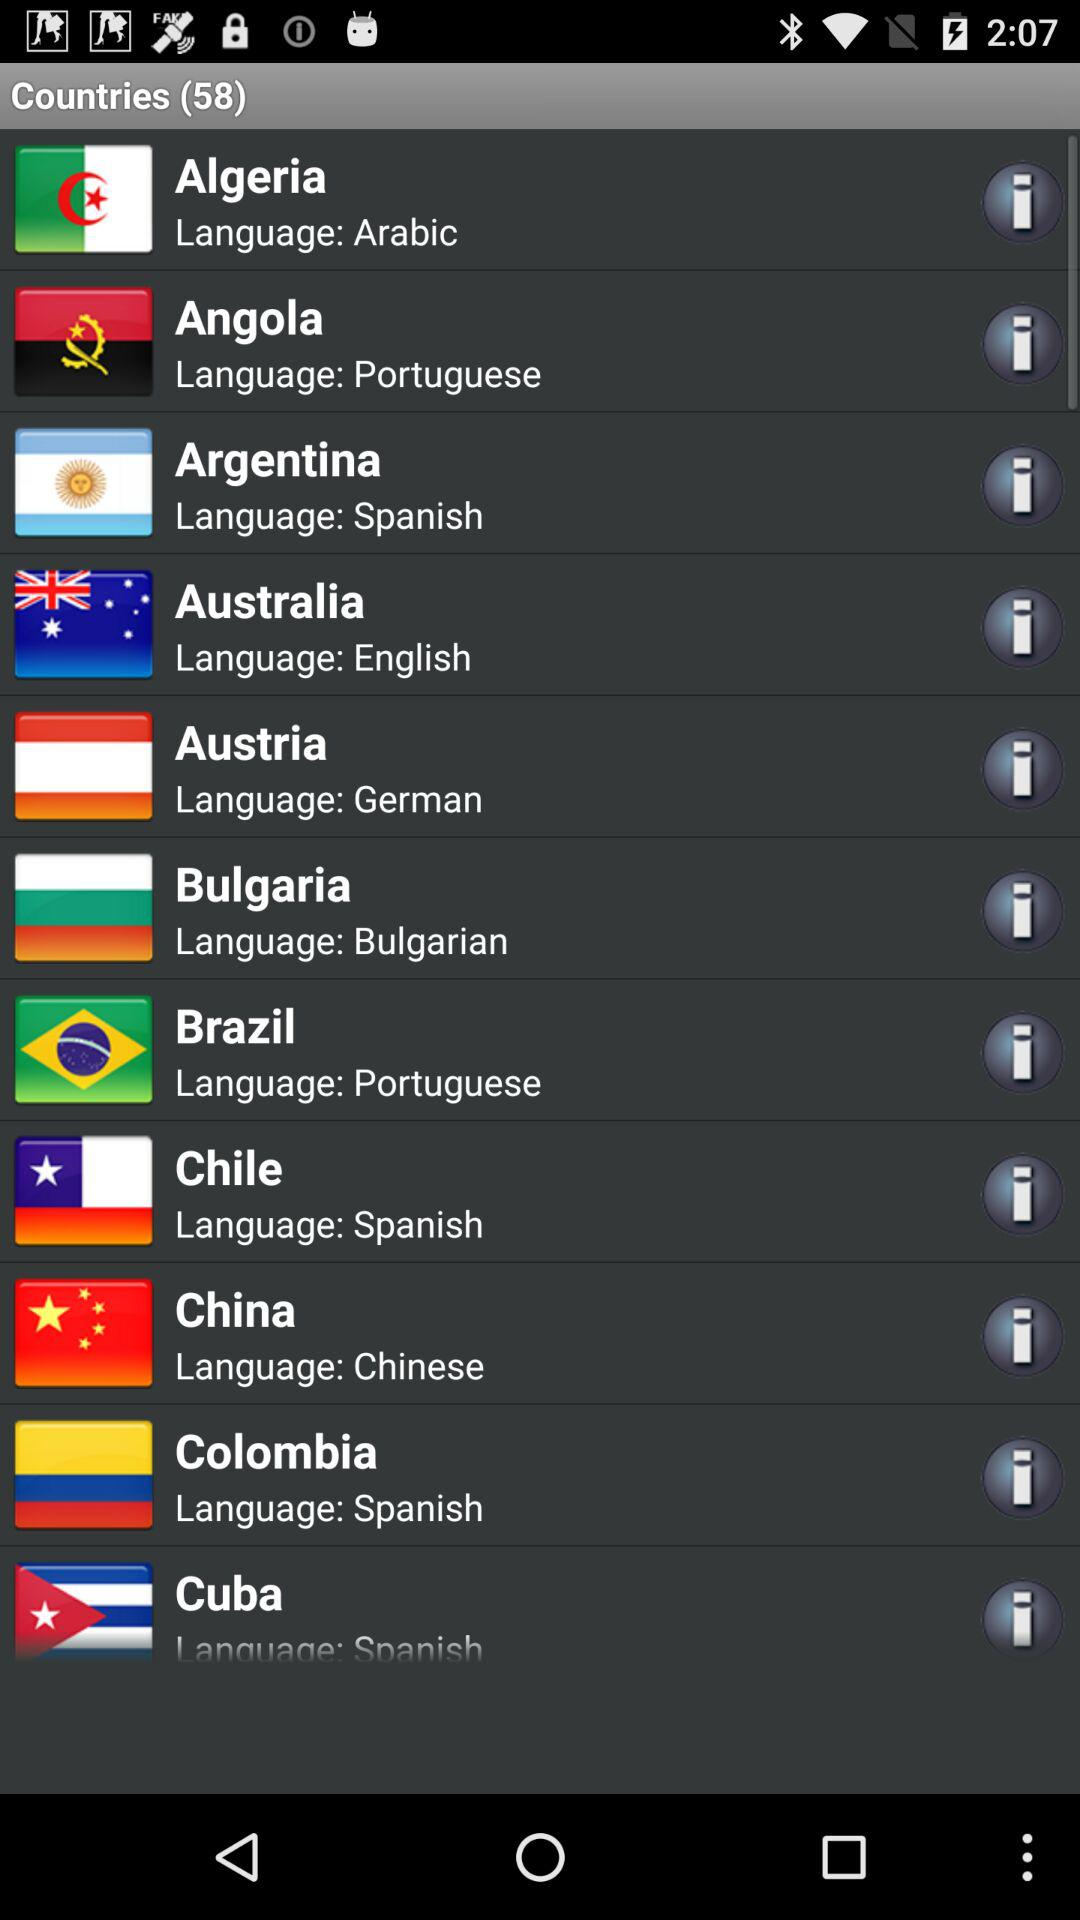How many countries are there? There are 58 countries. 